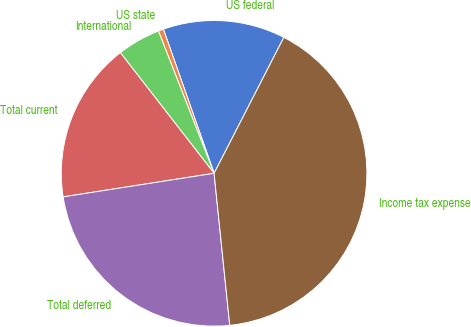<chart> <loc_0><loc_0><loc_500><loc_500><pie_chart><fcel>US federal<fcel>US state<fcel>International<fcel>Total current<fcel>Total deferred<fcel>Income tax expense<nl><fcel>12.93%<fcel>0.55%<fcel>4.58%<fcel>16.95%<fcel>24.17%<fcel>40.82%<nl></chart> 